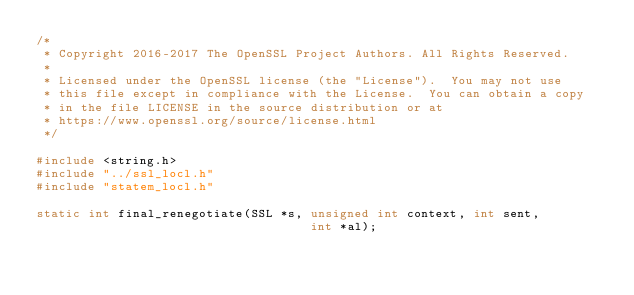Convert code to text. <code><loc_0><loc_0><loc_500><loc_500><_C_>/*
 * Copyright 2016-2017 The OpenSSL Project Authors. All Rights Reserved.
 *
 * Licensed under the OpenSSL license (the "License").  You may not use
 * this file except in compliance with the License.  You can obtain a copy
 * in the file LICENSE in the source distribution or at
 * https://www.openssl.org/source/license.html
 */

#include <string.h>
#include "../ssl_locl.h"
#include "statem_locl.h"

static int final_renegotiate(SSL *s, unsigned int context, int sent,
                                     int *al);</code> 